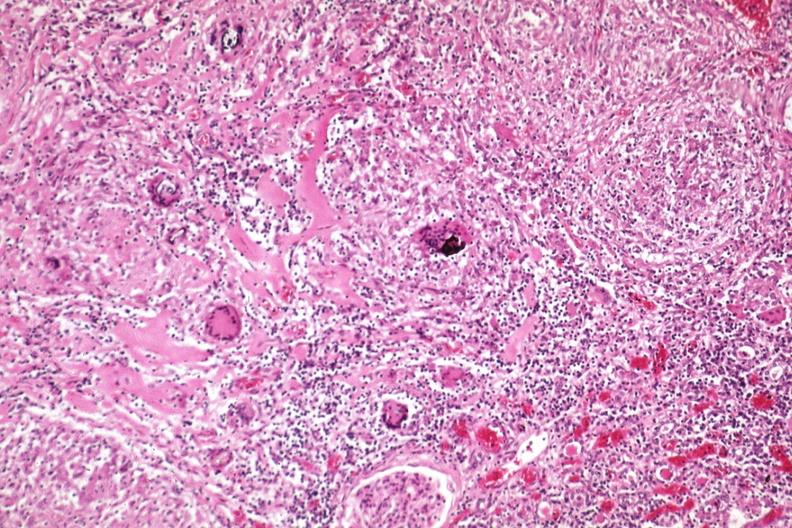where is this?
Answer the question using a single word or phrase. Urinary 